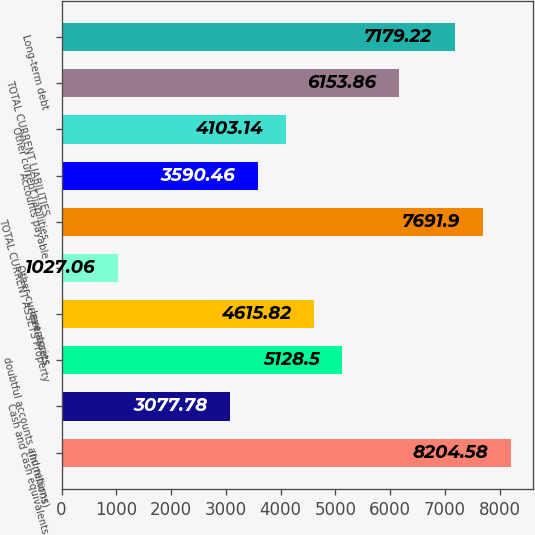<chart> <loc_0><loc_0><loc_500><loc_500><bar_chart><fcel>(In millions)<fcel>Cash and cash equivalents<fcel>doubtful accounts and returns<fcel>Inventories<fcel>Other current assets<fcel>TOTAL CURRENT ASSETS Property<fcel>Accounts payable<fcel>Other current liabilities<fcel>TOTAL CURRENT LIABILITIES<fcel>Long-term debt<nl><fcel>8204.58<fcel>3077.78<fcel>5128.5<fcel>4615.82<fcel>1027.06<fcel>7691.9<fcel>3590.46<fcel>4103.14<fcel>6153.86<fcel>7179.22<nl></chart> 